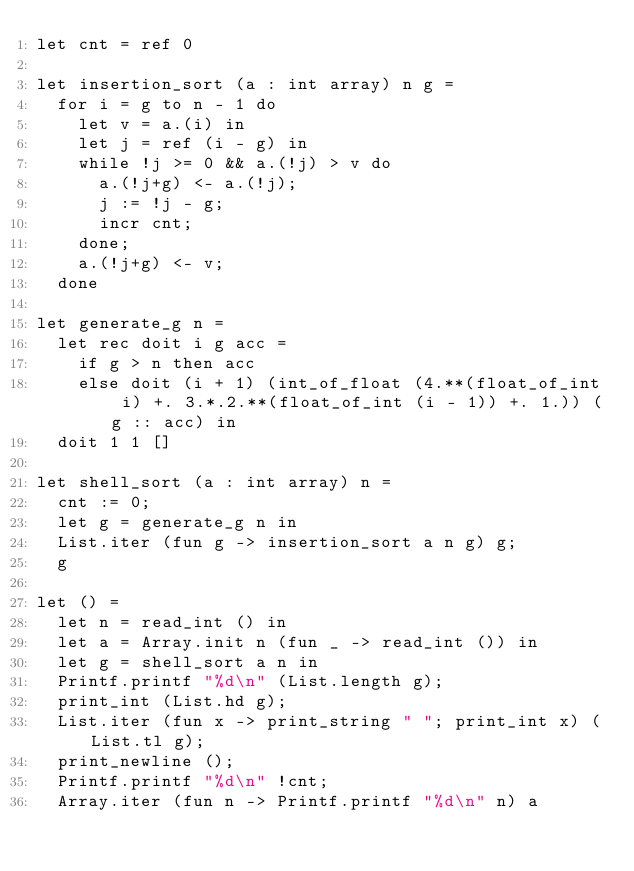Convert code to text. <code><loc_0><loc_0><loc_500><loc_500><_OCaml_>let cnt = ref 0

let insertion_sort (a : int array) n g =
  for i = g to n - 1 do
    let v = a.(i) in
    let j = ref (i - g) in
    while !j >= 0 && a.(!j) > v do
      a.(!j+g) <- a.(!j);
      j := !j - g;
      incr cnt;
    done;
    a.(!j+g) <- v;
  done

let generate_g n =
  let rec doit i g acc =
    if g > n then acc
    else doit (i + 1) (int_of_float (4.**(float_of_int i) +. 3.*.2.**(float_of_int (i - 1)) +. 1.)) (g :: acc) in
  doit 1 1 []

let shell_sort (a : int array) n =
  cnt := 0;
  let g = generate_g n in
  List.iter (fun g -> insertion_sort a n g) g;
  g

let () =
  let n = read_int () in
  let a = Array.init n (fun _ -> read_int ()) in
  let g = shell_sort a n in
  Printf.printf "%d\n" (List.length g);
  print_int (List.hd g);
  List.iter (fun x -> print_string " "; print_int x) (List.tl g);
  print_newline ();
  Printf.printf "%d\n" !cnt;
  Array.iter (fun n -> Printf.printf "%d\n" n) a</code> 